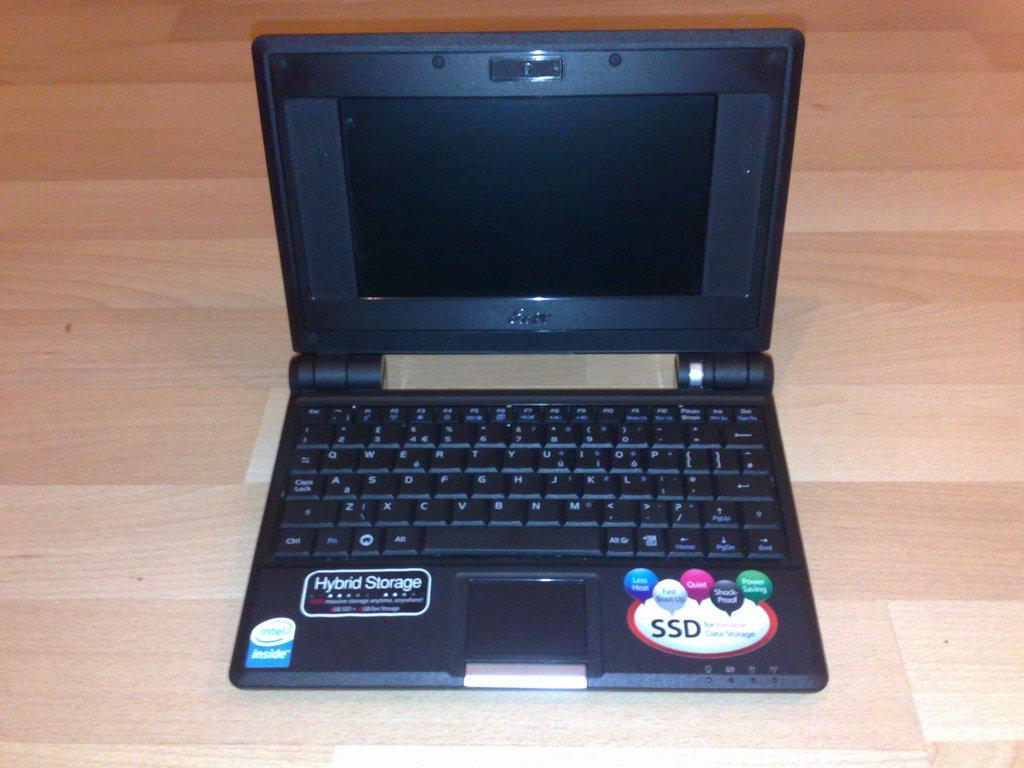<image>
Share a concise interpretation of the image provided. An open laptop with an Intel processor and Hybrid SSD storage. 